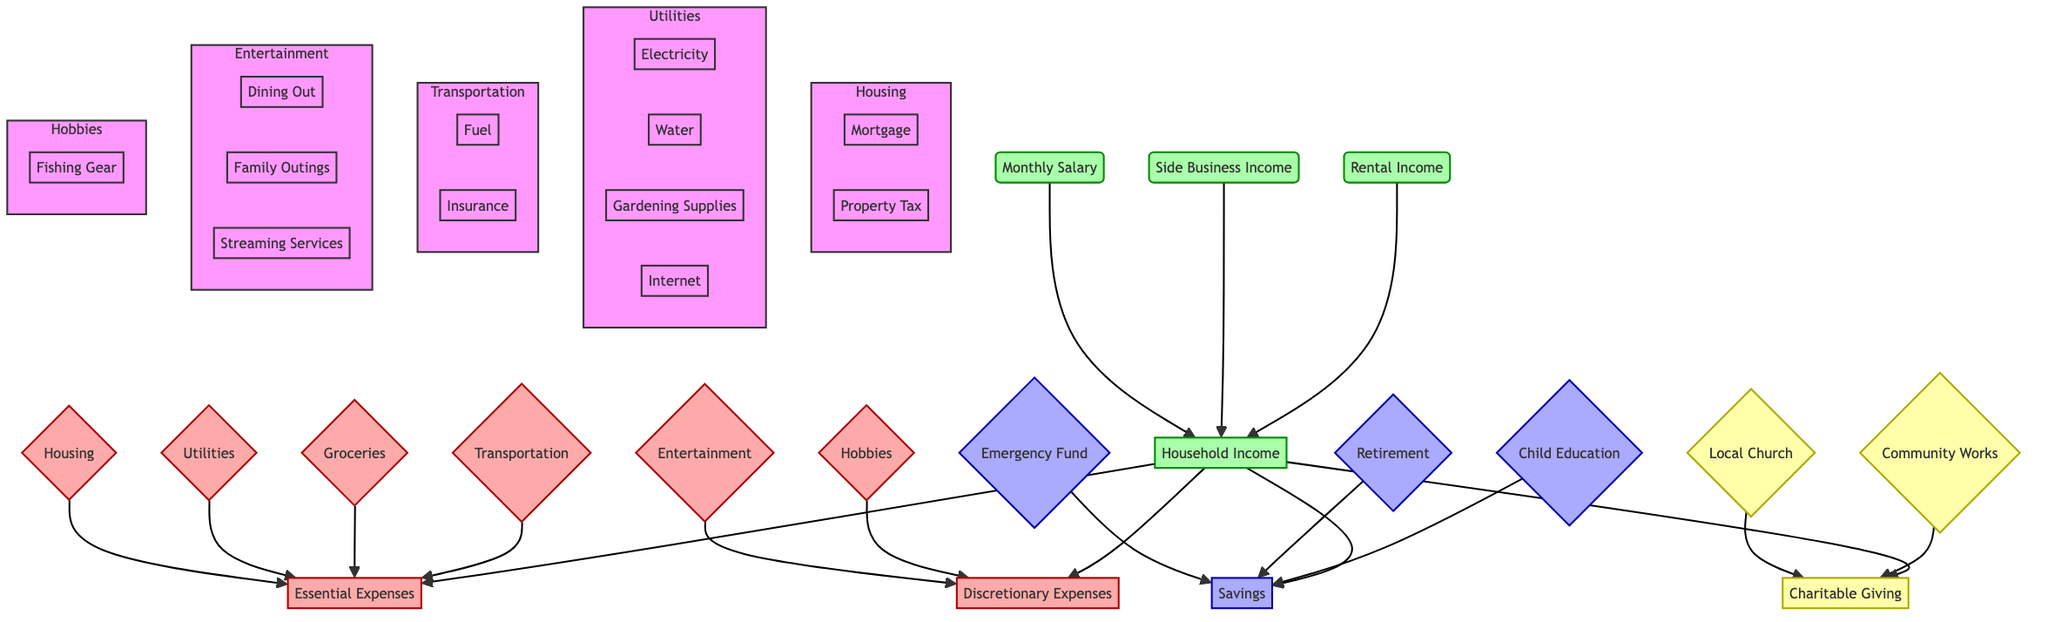What is the main source of household income? The diagram indicates that the main source of household income is the monthly salary, which is represented at the top of the income section.
Answer: Monthly Salary How many types of essential expenses are listed in the diagram? Essential expenses include housing, utilities, groceries, and transportation. Counting these categories gives us a total of four types.
Answer: 4 What are the supplemental sources of income? The diagram lists side business income and rental income as the two supplemental sources under the household income section.
Answer: Side Business Income, Rental Income Which category includes 'Streaming Services'? The category of discretionary expenses includes entertainment, where streaming services are listed as one of the options.
Answer: Discretionary Expenses How many components are there under utilities? The utilities section comprises four components: electricity, water, gas, and internet. Thus, there are four components in total.
Answer: 4 What is the relationship between household income and savings? The relationship is that the household income directly supports the savings, as indicated by the arrows leading from the household income node to the savings node in the diagram.
Answer: Direct relationship Which category of expenses has the most items listed? The essential expenses category has the most items, broken down into housing (two items), utilities (four items), groceries (one item), and transportation (two items), totaling nine items.
Answer: Essential Expenses What type of contributions are indicated under savings? The savings section consists of monthly contributions toward the emergency fund, retirement through 401(k), and child education through 529 plan contributions.
Answer: Monthly contributions What is the purpose of the charitable giving section? The charitable giving section represents contributions made to the local church and community works, showing the family's commitment to support local causes.
Answer: Support local causes 